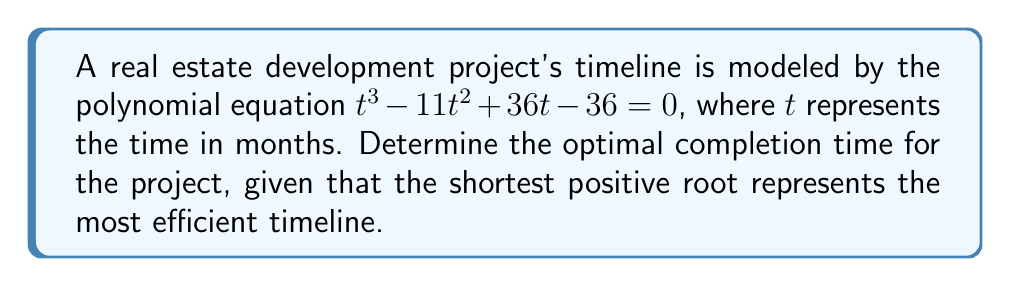Solve this math problem. To solve this polynomial equation and find the optimal completion time, we'll follow these steps:

1) First, we need to factor the polynomial $t^3 - 11t^2 + 36t - 36$.

2) We can see that 1 and 3 are factors of 36, so let's try $(t-1)$ and $(t-3)$ as potential factors:

   $t^3 - 11t^2 + 36t - 36 = (t-1)(t^2 - 10t + 36)$

3) Now we need to factor the quadratic term $t^2 - 10t + 36$:
   
   $t^2 - 10t + 36 = (t-4)(t-6)$

4) Therefore, the fully factored polynomial is:

   $t^3 - 11t^2 + 36t - 36 = (t-1)(t-4)(t-6)$

5) Setting this equal to zero:

   $(t-1)(t-4)(t-6) = 0$

6) The solutions to this equation are the values of $t$ that make any of these factors equal to zero:

   $t = 1$ or $t = 4$ or $t = 6$

7) Since we're looking for the shortest positive root, which represents the most efficient timeline, the optimal completion time is 1 month.
Answer: 1 month 